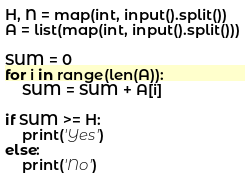<code> <loc_0><loc_0><loc_500><loc_500><_Python_>H, N = map(int, input().split())
A = list(map(int, input().split()))

SUM = 0
for i in range(len(A)):
    SUM = SUM + A[i]

if SUM >= H:
    print('Yes')
else:
    print('No')</code> 